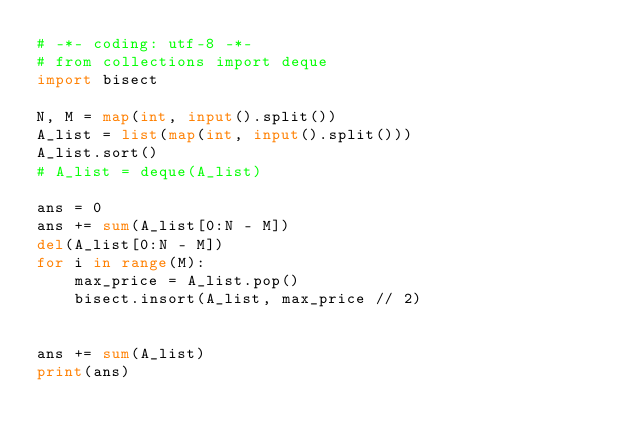<code> <loc_0><loc_0><loc_500><loc_500><_Python_># -*- coding: utf-8 -*-
# from collections import deque
import bisect

N, M = map(int, input().split())
A_list = list(map(int, input().split()))
A_list.sort()
# A_list = deque(A_list)

ans = 0
ans += sum(A_list[0:N - M])
del(A_list[0:N - M])
for i in range(M):
    max_price = A_list.pop()
    bisect.insort(A_list, max_price // 2)
    

ans += sum(A_list)
print(ans)</code> 